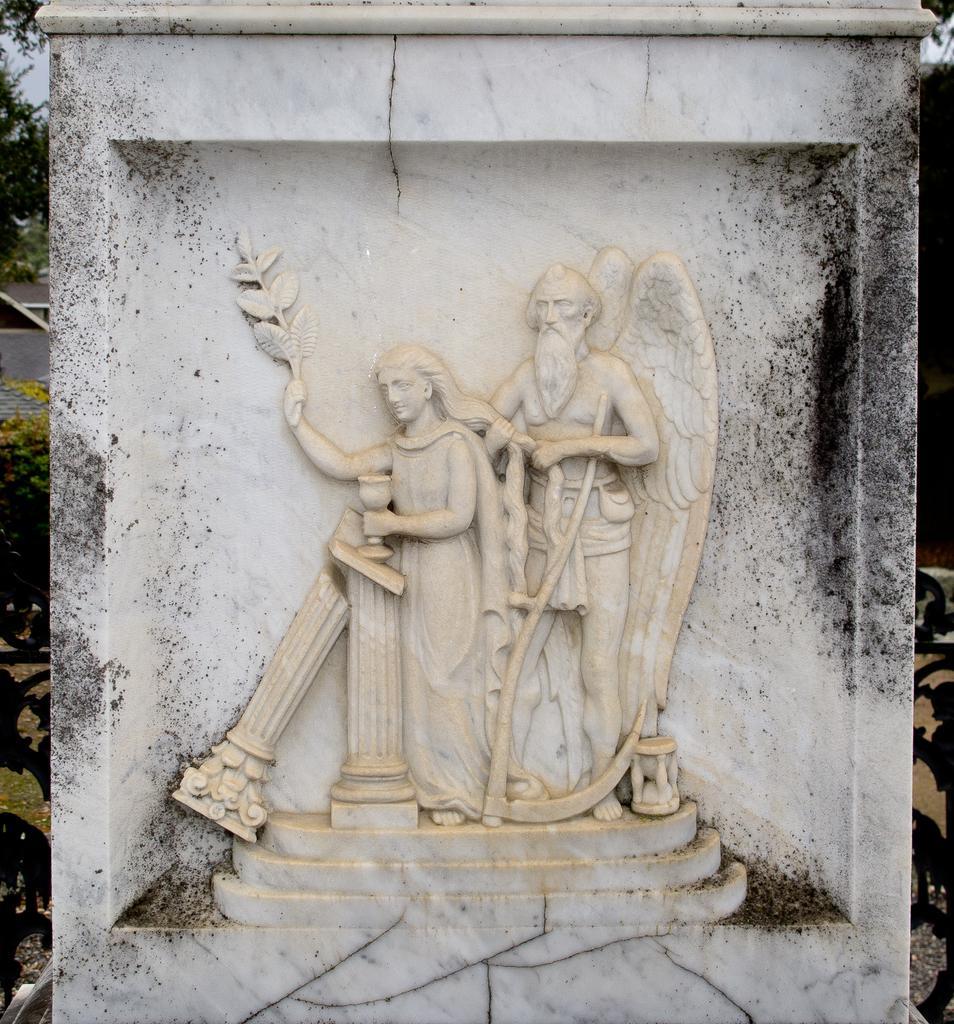How would you summarize this image in a sentence or two? In the picture I can see sculpture of a man, a woman and some other things. In the background I can see the sky and a tree. 